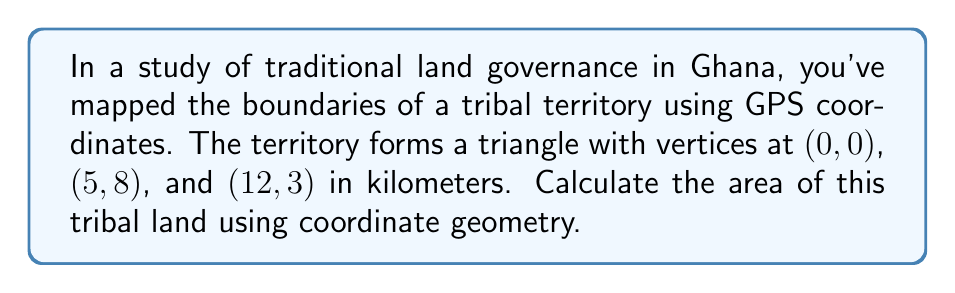Help me with this question. To find the area of the triangular tribal land, we can use the formula for the area of a triangle given the coordinates of its vertices:

$$ \text{Area} = \frac{1}{2}|x_1(y_2 - y_3) + x_2(y_3 - y_1) + x_3(y_1 - y_2)| $$

Where $(x_1, y_1)$, $(x_2, y_2)$, and $(x_3, y_3)$ are the coordinates of the three vertices.

Let's assign the coordinates:
$(x_1, y_1) = (0, 0)$
$(x_2, y_2) = (5, 8)$
$(x_3, y_3) = (12, 3)$

Now, let's substitute these values into the formula:

$$ \begin{align*}
\text{Area} &= \frac{1}{2}|0(8 - 3) + 5(3 - 0) + 12(0 - 8)| \\
&= \frac{1}{2}|0(5) + 5(3) + 12(-8)| \\
&= \frac{1}{2}|0 + 15 - 96| \\
&= \frac{1}{2}|-81| \\
&= \frac{1}{2}(81) \\
&= 40.5
\end{align*} $$

The area is 40.5 square kilometers.

[asy]
unitsize(10mm);
draw((0,0)--(5,8)--(12,3)--cycle);
label("(0,0)", (0,0), SW);
label("(5,8)", (5,8), N);
label("(12,3)", (12,3), SE);
[/asy]
Answer: 40.5 km² 